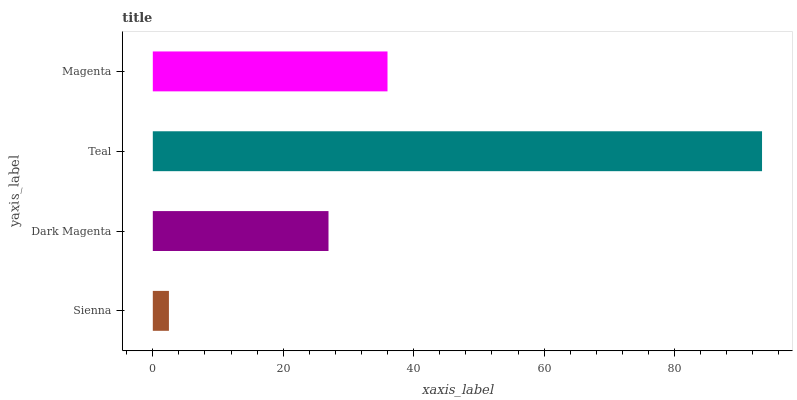Is Sienna the minimum?
Answer yes or no. Yes. Is Teal the maximum?
Answer yes or no. Yes. Is Dark Magenta the minimum?
Answer yes or no. No. Is Dark Magenta the maximum?
Answer yes or no. No. Is Dark Magenta greater than Sienna?
Answer yes or no. Yes. Is Sienna less than Dark Magenta?
Answer yes or no. Yes. Is Sienna greater than Dark Magenta?
Answer yes or no. No. Is Dark Magenta less than Sienna?
Answer yes or no. No. Is Magenta the high median?
Answer yes or no. Yes. Is Dark Magenta the low median?
Answer yes or no. Yes. Is Dark Magenta the high median?
Answer yes or no. No. Is Teal the low median?
Answer yes or no. No. 